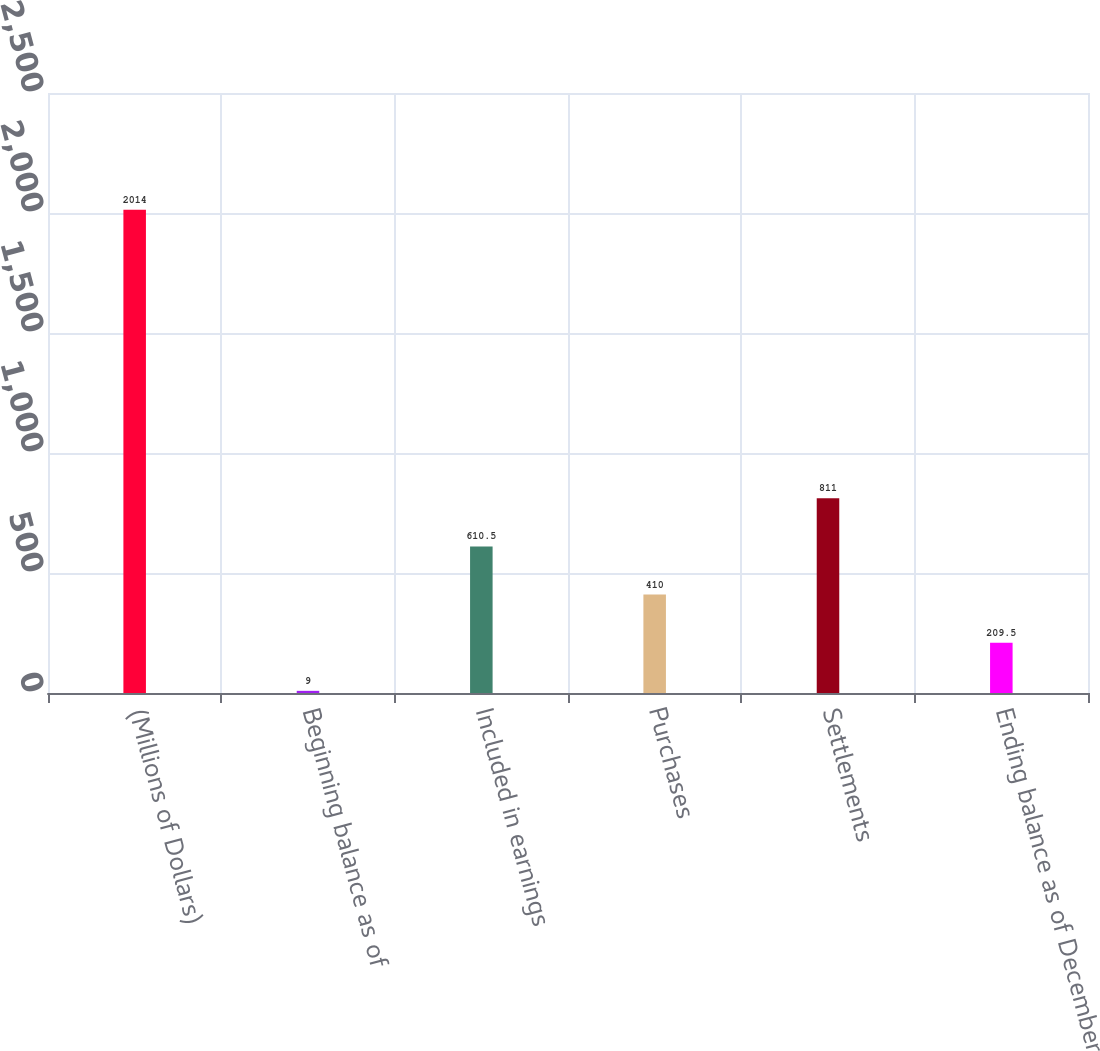Convert chart. <chart><loc_0><loc_0><loc_500><loc_500><bar_chart><fcel>(Millions of Dollars)<fcel>Beginning balance as of<fcel>Included in earnings<fcel>Purchases<fcel>Settlements<fcel>Ending balance as of December<nl><fcel>2014<fcel>9<fcel>610.5<fcel>410<fcel>811<fcel>209.5<nl></chart> 